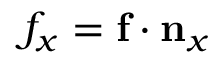<formula> <loc_0><loc_0><loc_500><loc_500>{ f } _ { x } = f \cdot n _ { x }</formula> 